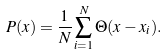<formula> <loc_0><loc_0><loc_500><loc_500>P ( x ) = \frac { 1 } { N } \sum _ { i = 1 } ^ { N } \Theta ( x - x _ { i } ) .</formula> 